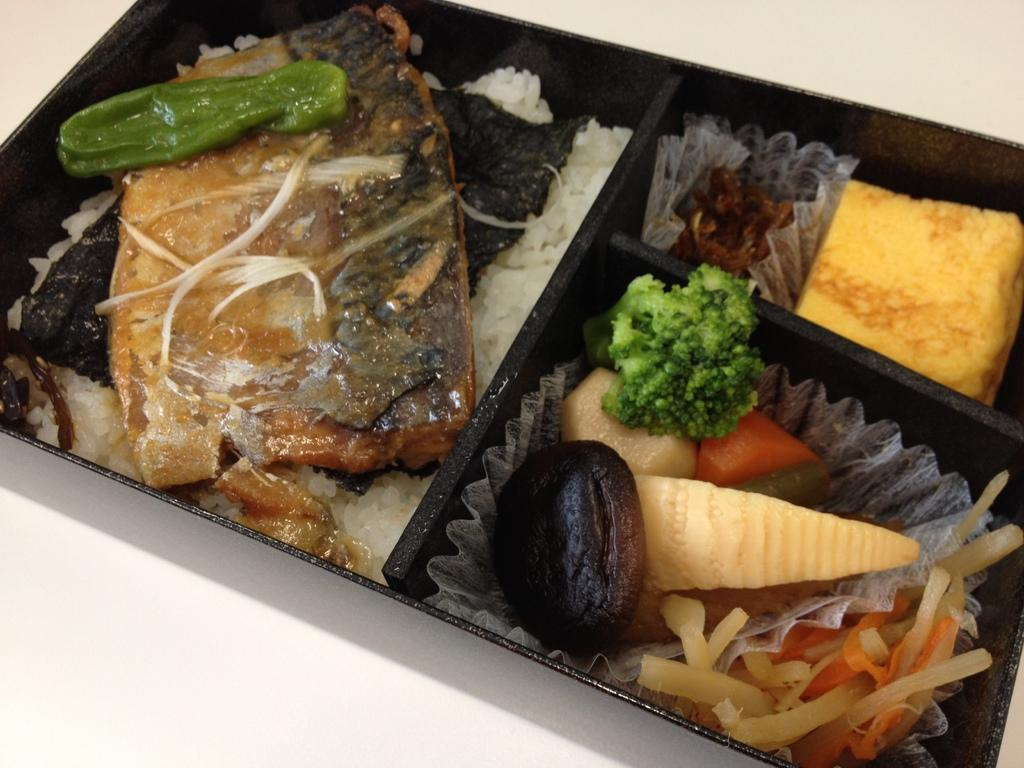What is in the bowl that is visible in the image? The bowl contains food. What can be inferred about the type of food in the bowl? The food in the bowl is not specified, but it is likely a type of dish or meal. Where is the bowl located in the image? The bowl is placed on a surface. What type of disease can be seen spreading through the food in the image? There is no disease present in the image, and the food's condition is not specified. How many lizards are crawling on the surface where the bowl is placed? There are no lizards present in the image; the surface where the bowl is placed is not specified. 